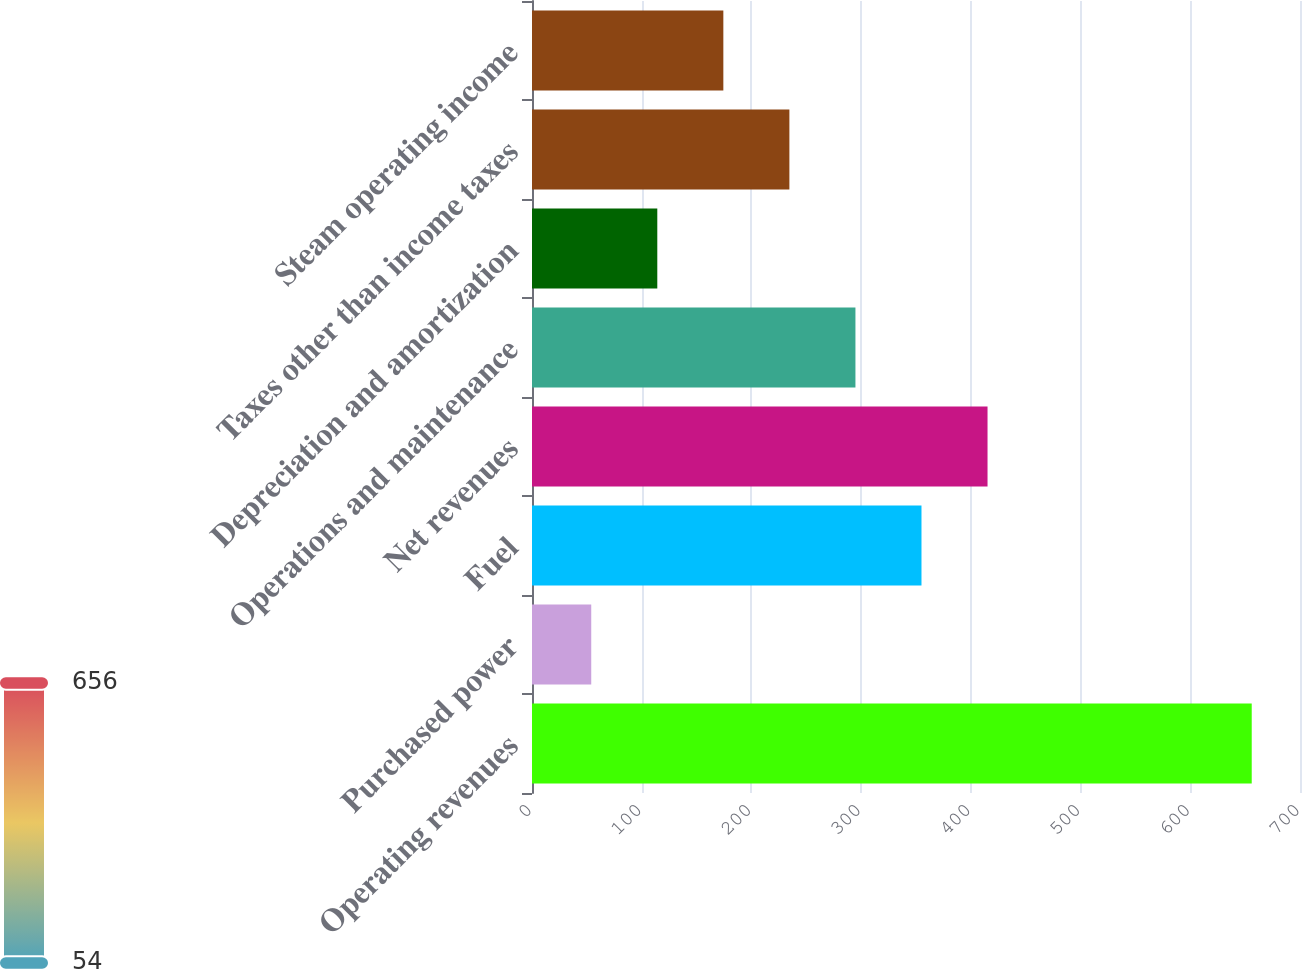Convert chart to OTSL. <chart><loc_0><loc_0><loc_500><loc_500><bar_chart><fcel>Operating revenues<fcel>Purchased power<fcel>Fuel<fcel>Net revenues<fcel>Operations and maintenance<fcel>Depreciation and amortization<fcel>Taxes other than income taxes<fcel>Steam operating income<nl><fcel>656<fcel>54<fcel>355<fcel>415.2<fcel>294.8<fcel>114.2<fcel>234.6<fcel>174.4<nl></chart> 